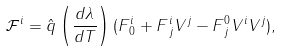Convert formula to latex. <formula><loc_0><loc_0><loc_500><loc_500>\mathcal { F } ^ { i } = \hat { q } \left ( \frac { d \lambda } { d T } \right ) ( F ^ { i } _ { \, 0 } + F ^ { i } _ { \, j } V ^ { j } - F ^ { 0 } _ { \, j } V ^ { i } V ^ { j } ) ,</formula> 